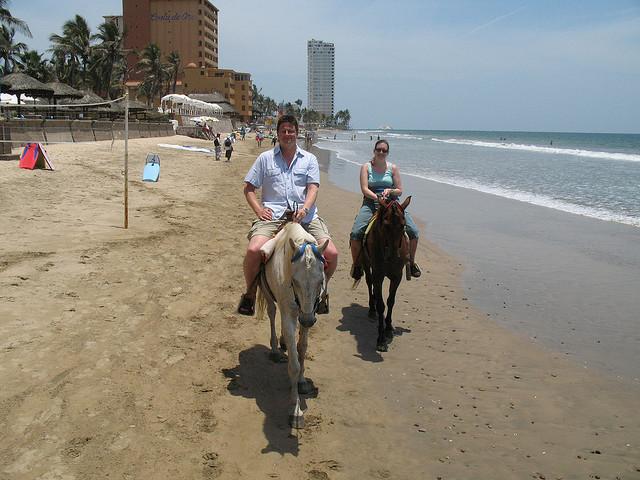What are the riders riding?
Answer briefly. Horses. What kind of game would be played near this spot?
Keep it brief. Volleyball. Is this a fully grown horse?
Quick response, please. Yes. Are the horses a male or female?
Give a very brief answer. Male. 